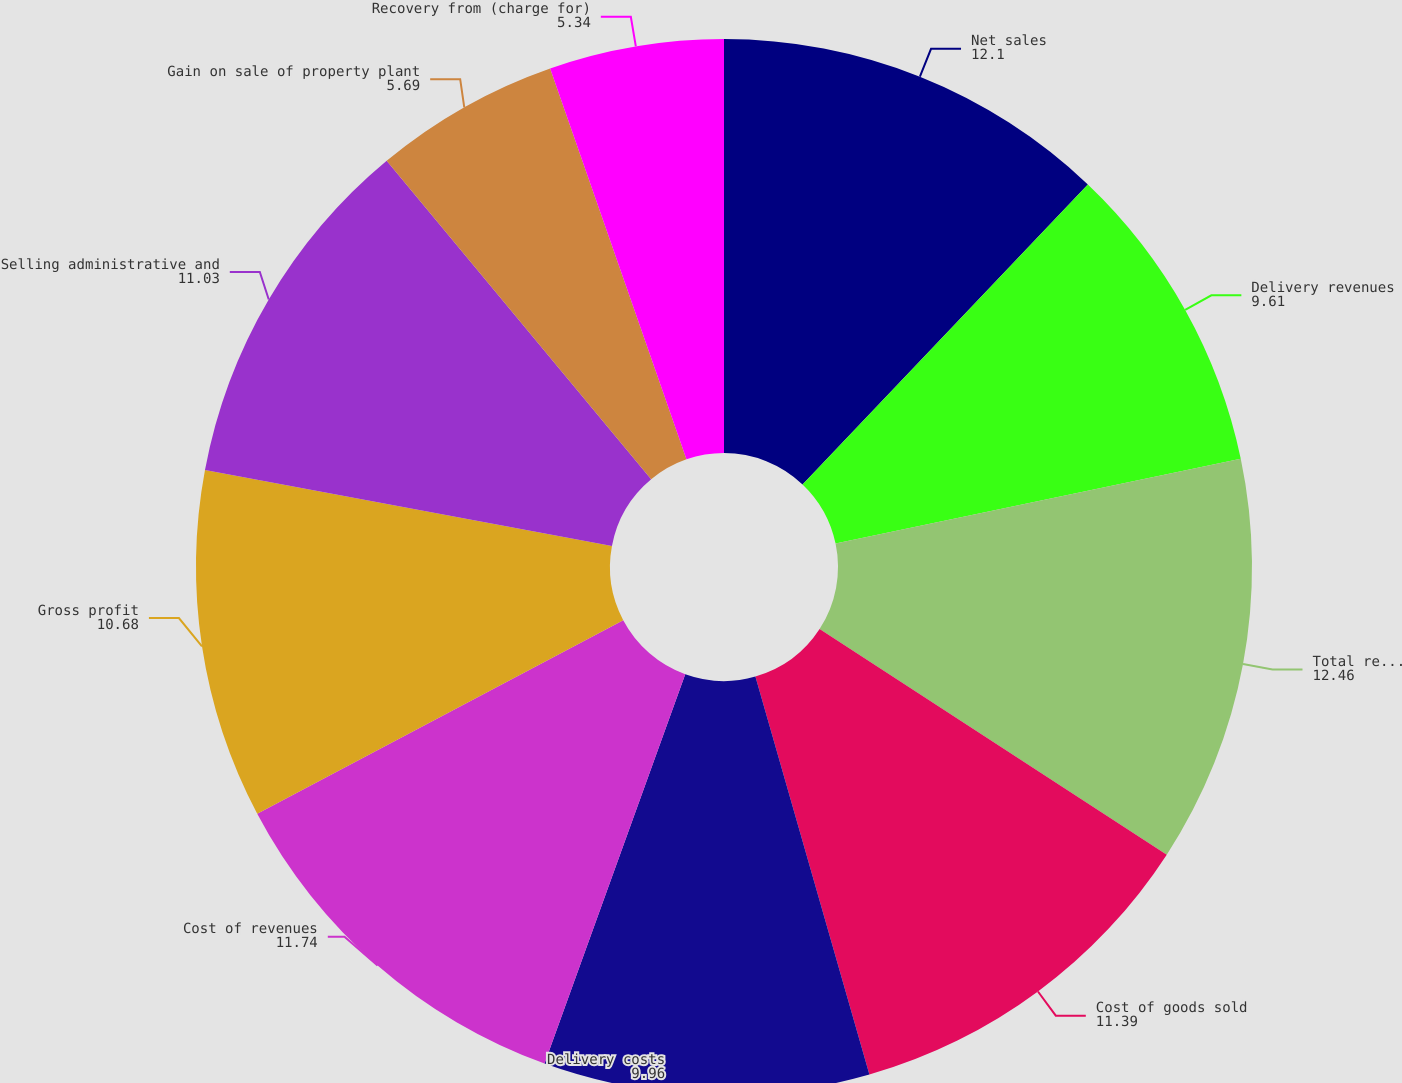<chart> <loc_0><loc_0><loc_500><loc_500><pie_chart><fcel>Net sales<fcel>Delivery revenues<fcel>Total revenues<fcel>Cost of goods sold<fcel>Delivery costs<fcel>Cost of revenues<fcel>Gross profit<fcel>Selling administrative and<fcel>Gain on sale of property plant<fcel>Recovery from (charge for)<nl><fcel>12.1%<fcel>9.61%<fcel>12.46%<fcel>11.39%<fcel>9.96%<fcel>11.74%<fcel>10.68%<fcel>11.03%<fcel>5.69%<fcel>5.34%<nl></chart> 